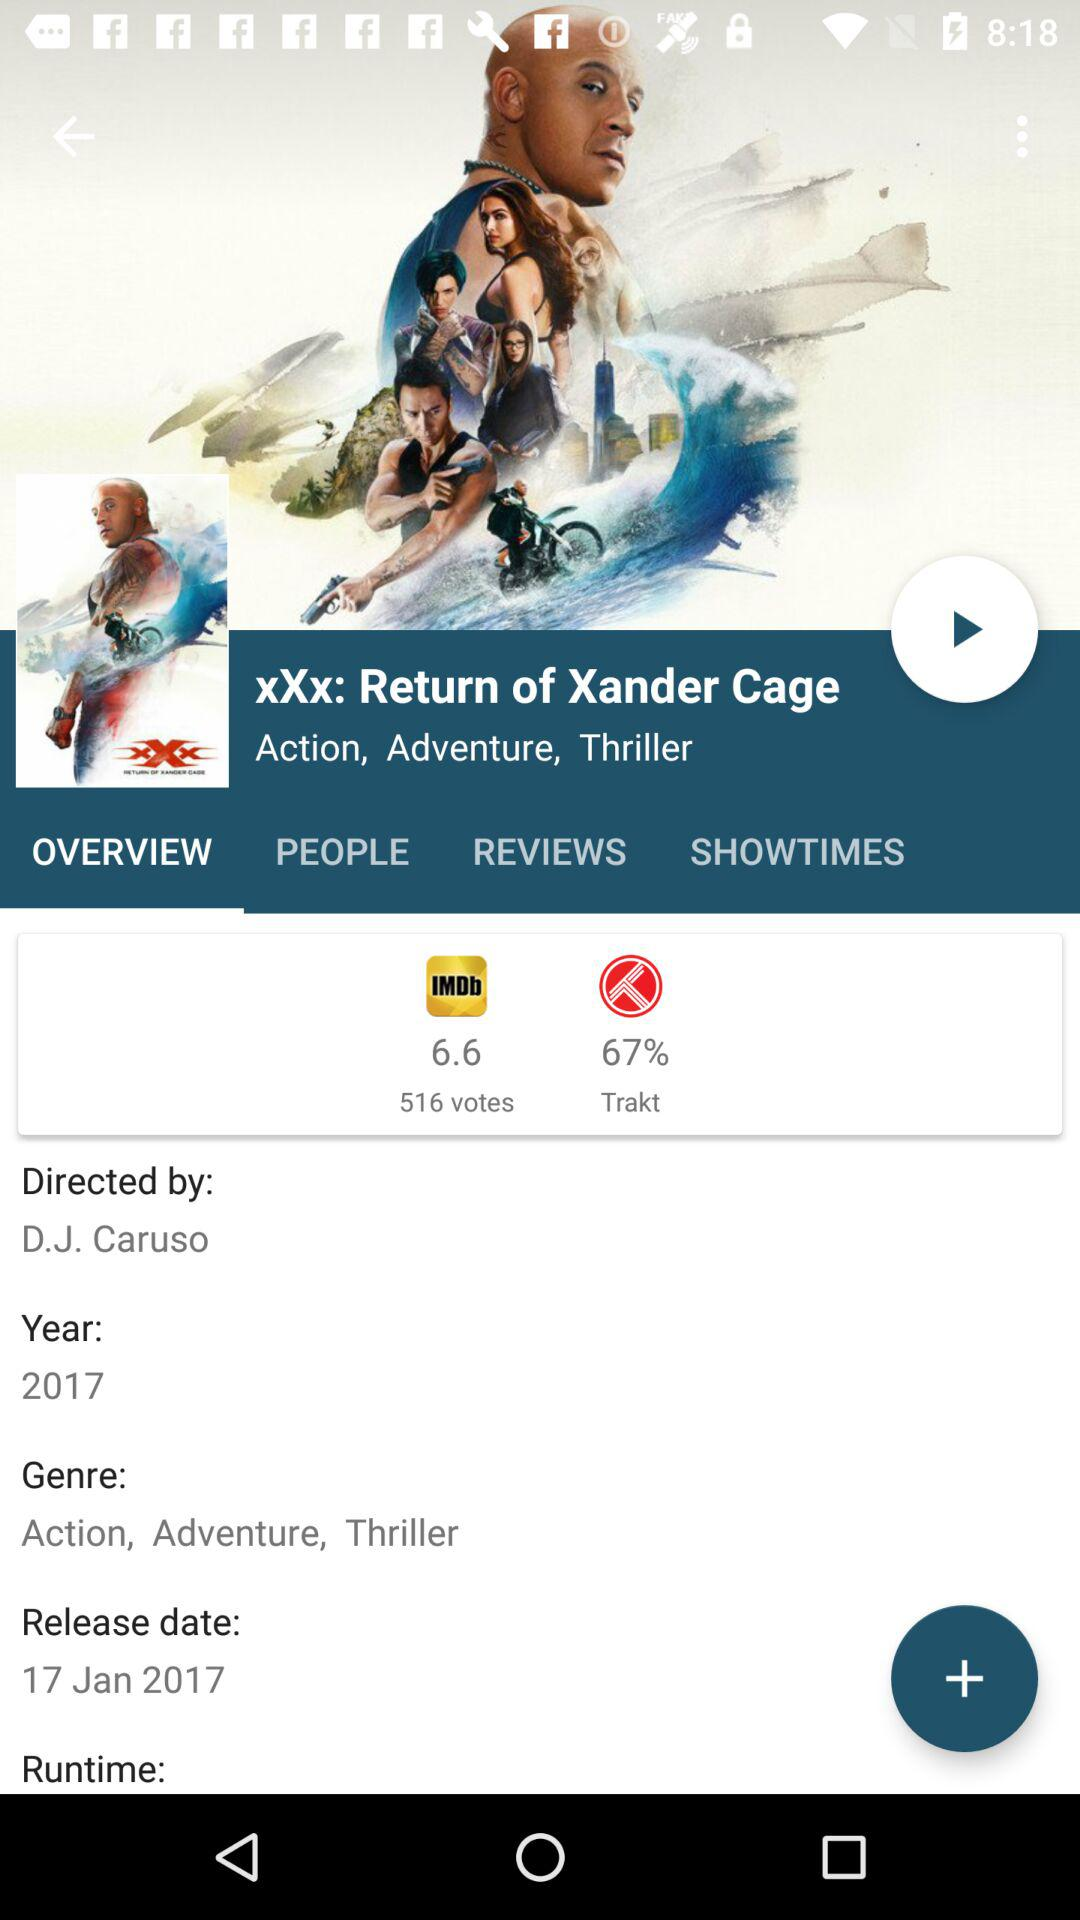What is the release date? The release date is January 17, 2017. 